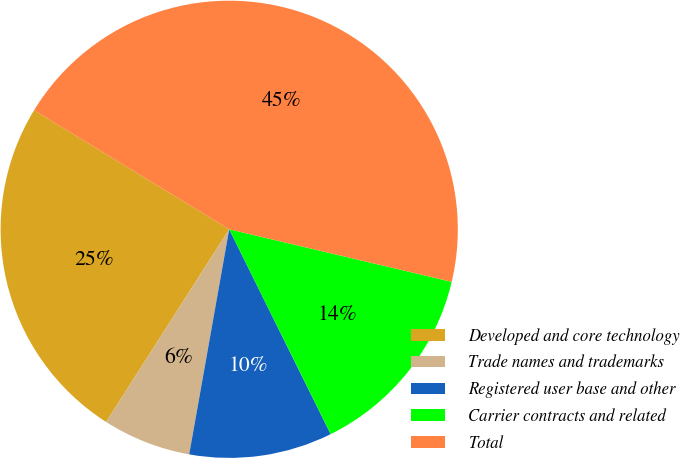<chart> <loc_0><loc_0><loc_500><loc_500><pie_chart><fcel>Developed and core technology<fcel>Trade names and trademarks<fcel>Registered user base and other<fcel>Carrier contracts and related<fcel>Total<nl><fcel>24.67%<fcel>6.25%<fcel>10.12%<fcel>13.99%<fcel>44.97%<nl></chart> 